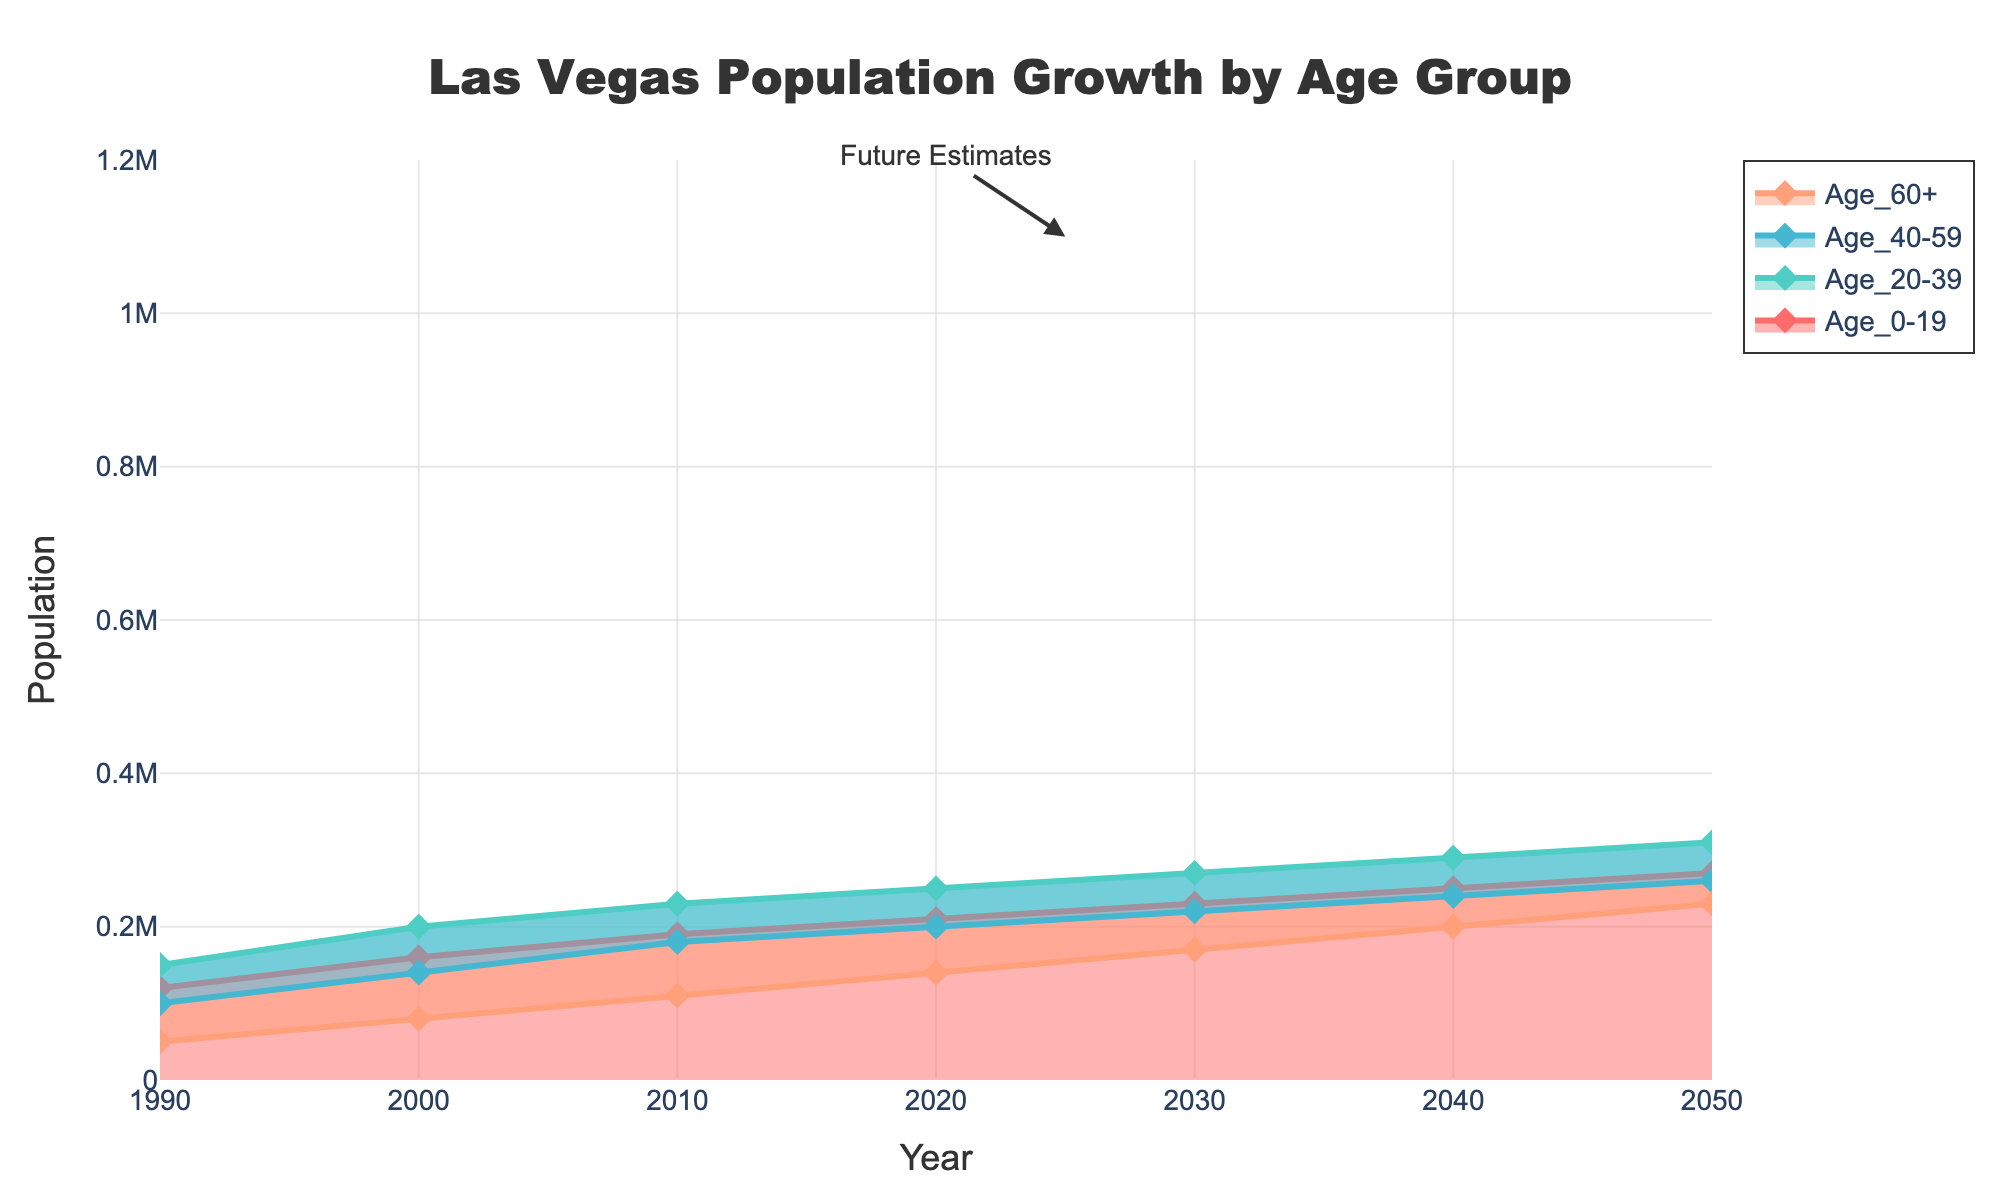Which age group had the largest population in 1990? Look at the values for each age group in 1990. Age_20-39 had the largest population with 150,000.
Answer: Age_20-39 In which year is the total population projected to be 890,000? Identify the year corresponding to the total population of 890,000. This is in 2030.
Answer: 2030 By how much did the Age_60+ population increase from 1990 to 2000? Subtract the population value of Age_60+ in 1990 from the value in 2000. This gives you 80,000 - 50,000 = 30,000.
Answer: 30,000 What is the total increase in the Age_20-39 population from 1990 to 2050? Calculate the difference between the 2050 and 1990 values for the Age_20-39 group. This is 310,000 - 150,000 = 160,000.
Answer: 160,000 Which age group shows the smallest population growth from 1990 to 2050? Calculate the growth for each age group (2050 value - 1990 value) and find the smallest one. Age_0-19 grows by 270,000 - 120,000 = 150,000, Age_20-39 by 160,000, Age_40-59 by 160,000, and Age_60+ by 180,000. The smallest growth is in the Age_0-19 group.
Answer: Age_0-19 What is the combined population of Age_0-19 and Age_20-39 in 2050? Add the values for Age_0-19 and Age_20-39 in 2050. This is 270,000 + 310,000 = 580,000.
Answer: 580,000 Which age group has the highest estimated population in 2040? Look at the values for each age group in 2040. Age_20-39 has the highest estimated population with 290,000.
Answer: Age_20-39 How does the population of Age_60+ in 2020 compare to 2010? Compare the values of Age_60+ in 2020 and 2010. 2020's value (140,000) is higher than 2010's (110,000) by 30,000.
Answer: Increased by 30,000 Which year shows the biggest increase in total population compared to the previous decade? Calculate the difference in total population between each consecutive decade. The differences are: 2000-1990: 580,000-420,000 = 160,000, 2010-2000: 710,000-580,000 = 130,000, 2020-2010: 800,000-710,000 = 90,000, 2030-2020: 890,000-800,000 = 90,000, 2040-2030: 980,000-890,000 = 90,000, 2050-2040: 1,070,000-980,000 = 90,000. The biggest increase is from 1990 to 2000.
Answer: 1990-2000 During which decade does the Age_40-59 group grow the most? Calculate the growth for each decade (next decade - current decade) for Age_40-59. The biggest growth is 2000 (140,000) to 2010 (180,000), which is a difference of 40,000.
Answer: 2000-2010 